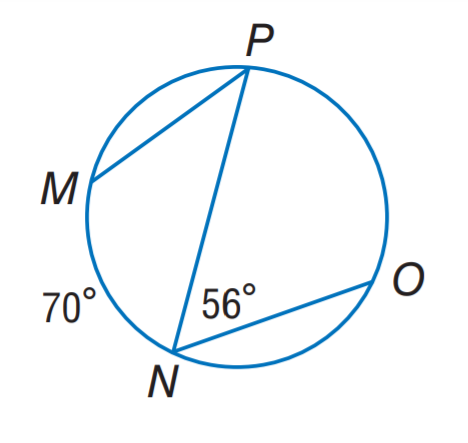Answer the mathemtical geometry problem and directly provide the correct option letter.
Question: Find m \widehat P O.
Choices: A: 56 B: 70 C: 112 D: 140 C 